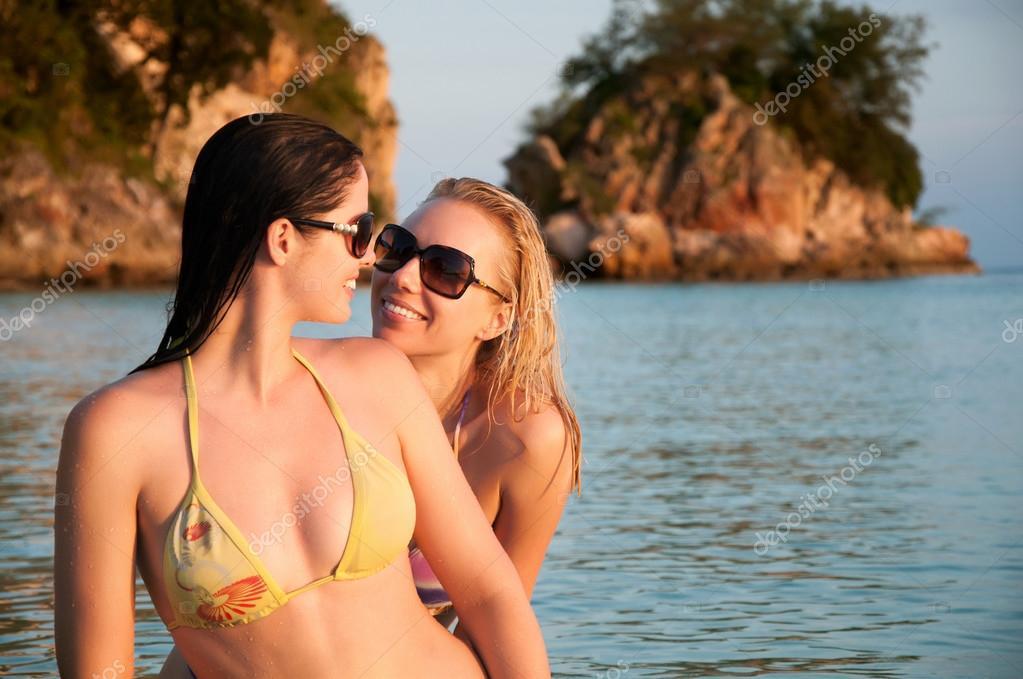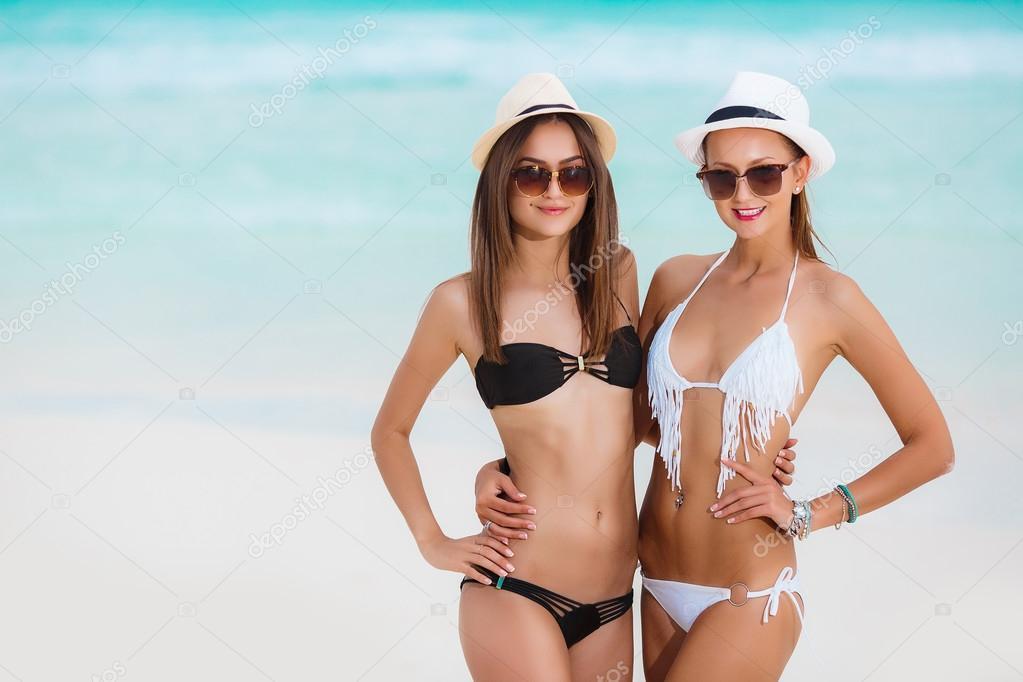The first image is the image on the left, the second image is the image on the right. For the images displayed, is the sentence "At least one woman has her hand on her hips." factually correct? Answer yes or no. Yes. The first image is the image on the left, the second image is the image on the right. Analyze the images presented: Is the assertion "A female is wearing a yellow bikini." valid? Answer yes or no. Yes. 